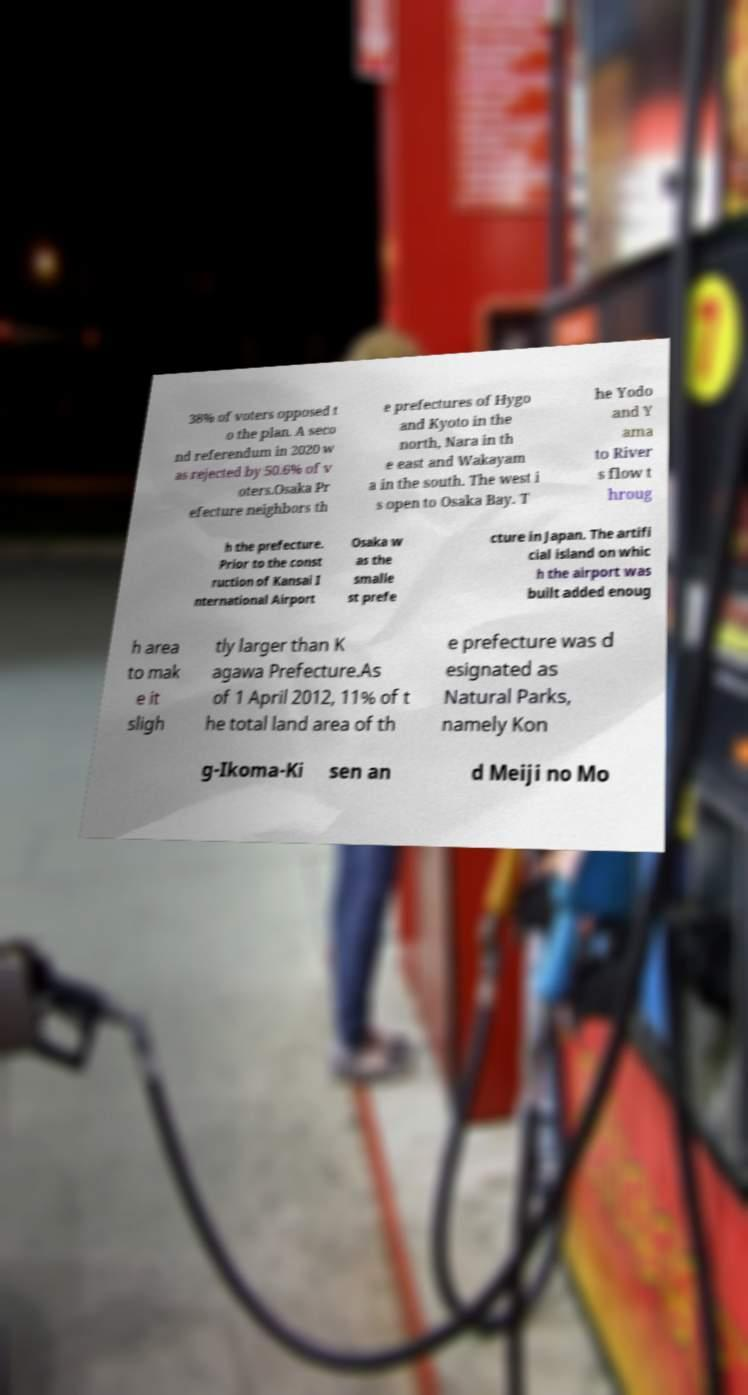Could you extract and type out the text from this image? 38% of voters opposed t o the plan. A seco nd referendum in 2020 w as rejected by 50.6% of v oters.Osaka Pr efecture neighbors th e prefectures of Hygo and Kyoto in the north, Nara in th e east and Wakayam a in the south. The west i s open to Osaka Bay. T he Yodo and Y ama to River s flow t hroug h the prefecture. Prior to the const ruction of Kansai I nternational Airport Osaka w as the smalle st prefe cture in Japan. The artifi cial island on whic h the airport was built added enoug h area to mak e it sligh tly larger than K agawa Prefecture.As of 1 April 2012, 11% of t he total land area of th e prefecture was d esignated as Natural Parks, namely Kon g-Ikoma-Ki sen an d Meiji no Mo 